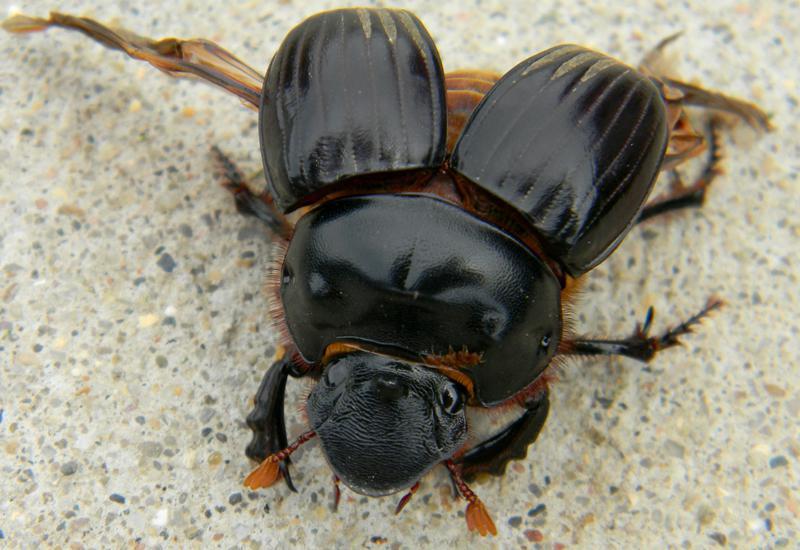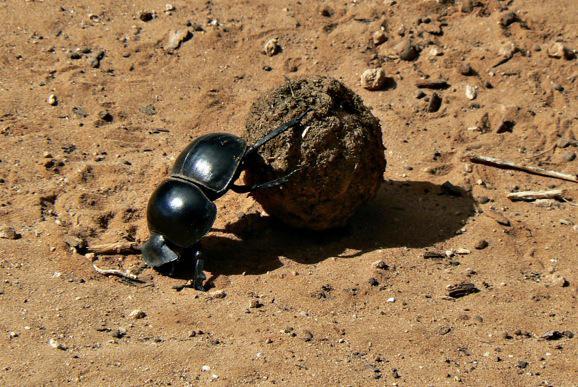The first image is the image on the left, the second image is the image on the right. Given the left and right images, does the statement "The right image contains a dung ball." hold true? Answer yes or no. Yes. 